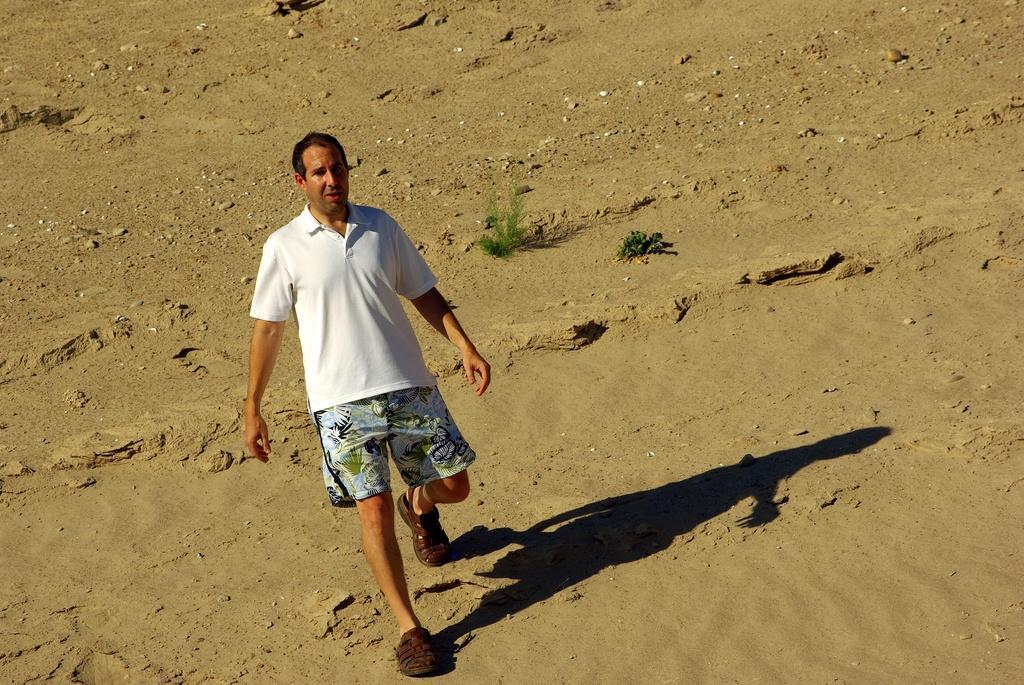How would you summarize this image in a sentence or two? There is a man in the foreground area of the image. 